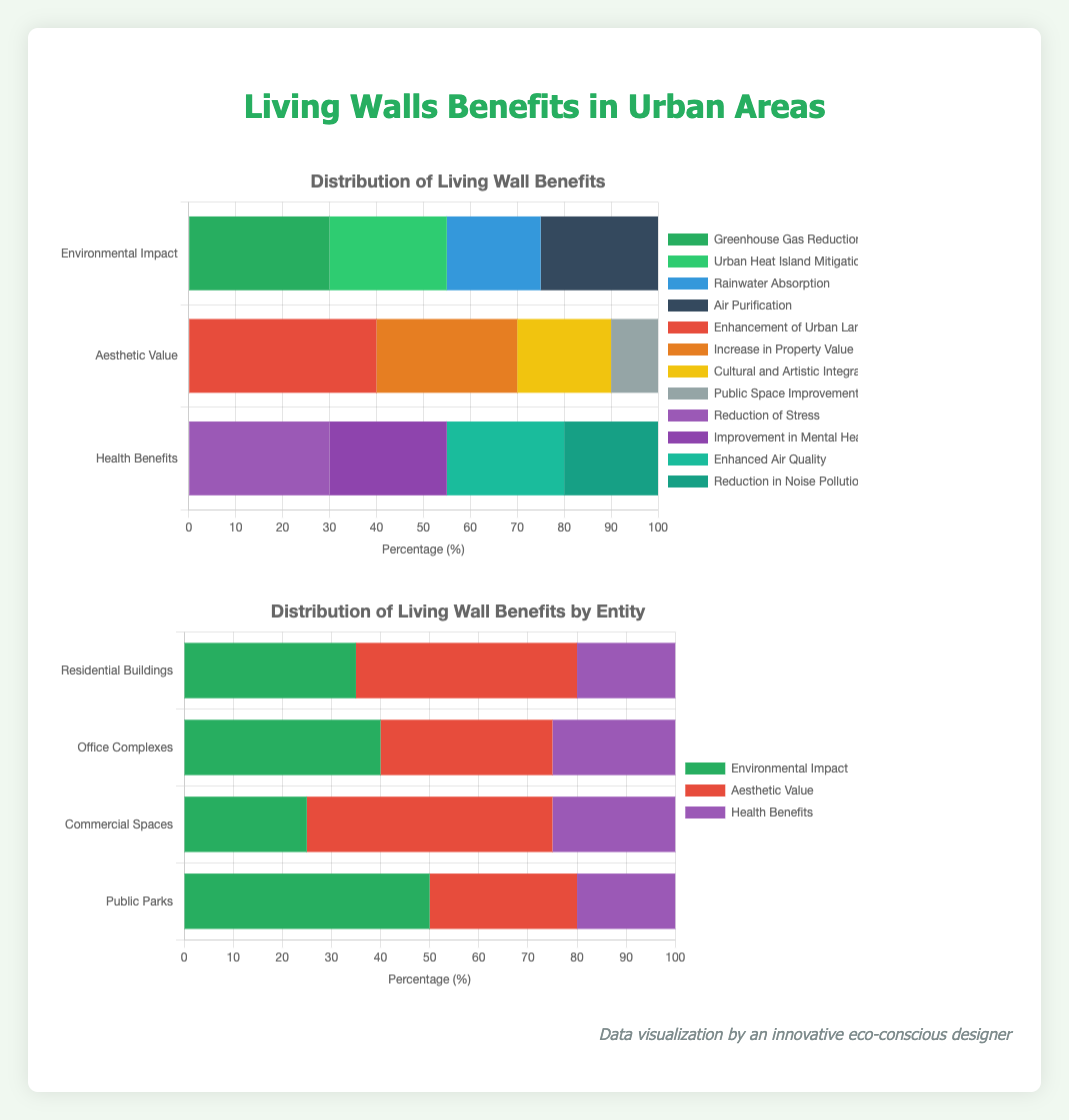Which benefit of living walls has the highest percentage contribution in the category of Health Benefits? The category 'Health Benefits' contains four benefits: "Reduction of Stress" (30%), "Improvement in Mental Health" (25%), "Enhanced Air Quality" (25%), and "Reduction in Noise Pollution" (20%). Among these, "Reduction of Stress" has the highest percentage contribution.
Answer: Reduction of Stress How does the percentage of 'Aesthetic Value' benefits in Residential Buildings compare to Office Complexes? The percentage contribution of 'Aesthetic Value' in Residential Buildings is 45%, while in Office Complexes, it is 35%. Residential Buildings have a higher percentage of 'Aesthetic Value' benefits compared to Office Complexes.
Answer: Residential Buildings have a higher percentage What is the total percentage contribution of 'Urban Heat Island Mitigation' and 'Air Purification' within the Environmental Impact category? Within the 'Environmental Impact' category, 'Urban Heat Island Mitigation' contributes 25%, and 'Air Purification' contributes 25%. Their total contribution is 25% + 25% = 50%.
Answer: 50% In which entity is the impact of living walls on 'Health Benefits' and 'Environmental Impact' closest in percentage? For each entity, the contributions of Health Benefits and Environmental Impact are as follows: Residential Buildings (20% and 35%), Office Complexes (25% and 40%), Commercial Spaces (25% and 25%), Public Parks (20% and 50%). The percentages are closest in Commercial Spaces where both are 25%.
Answer: Commercial Spaces What is the combined percentage of 'Enhancement of Urban Landscapes' and 'Increase in Property Value' within the Aesthetic Value category? 'Enhancement of Urban Landscapes' contributes 40% and 'Increase in Property Value' contributes 30% within the Aesthetic Value category. Their combined percentage is 40% + 30% = 70%.
Answer: 70% Which entity has the lowest percentage for 'Aesthetic Value', and what is this percentage? The percentages for 'Aesthetic Value' are as follows: Residential Buildings (45%), Office Complexes (35%), Commercial Spaces (50%), and Public Parks (30%). Public Parks have the lowest percentage for 'Aesthetic Value', which is 30%.
Answer: Public Parks at 30% What is the difference in percentage between 'Greenhouse Gas Reduction' and 'Rainwater Absorption' within the Environmental Impact category? 'Greenhouse Gas Reduction' has a percentage of 30%, and 'Rainwater Absorption' has a percentage of 20% within the Environmental Impact category. The difference is 30% - 20% = 10%.
Answer: 10% 